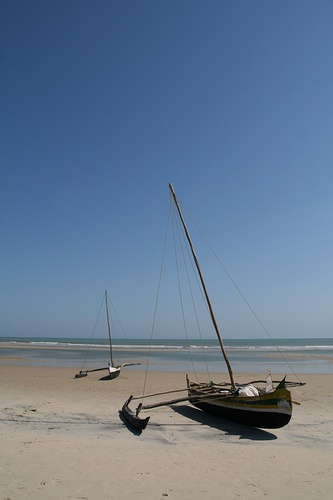Describe the objects in this image and their specific colors. I can see boat in darkblue, gray, darkgray, and black tones and boat in darkblue and gray tones in this image. 